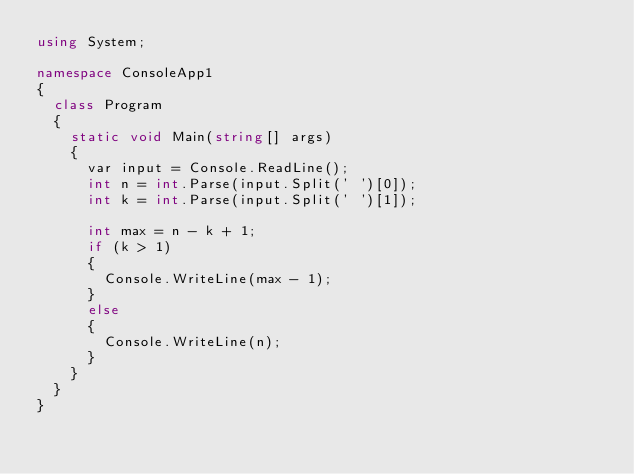Convert code to text. <code><loc_0><loc_0><loc_500><loc_500><_C#_>using System;

namespace ConsoleApp1
{
	class Program
	{
		static void Main(string[] args)
		{
			var input = Console.ReadLine();
			int n = int.Parse(input.Split(' ')[0]);
			int k = int.Parse(input.Split(' ')[1]);

			int max = n - k + 1;
			if (k > 1)
			{
				Console.WriteLine(max - 1);
			}
			else
			{
				Console.WriteLine(n);
			}
		}
	}
}
</code> 